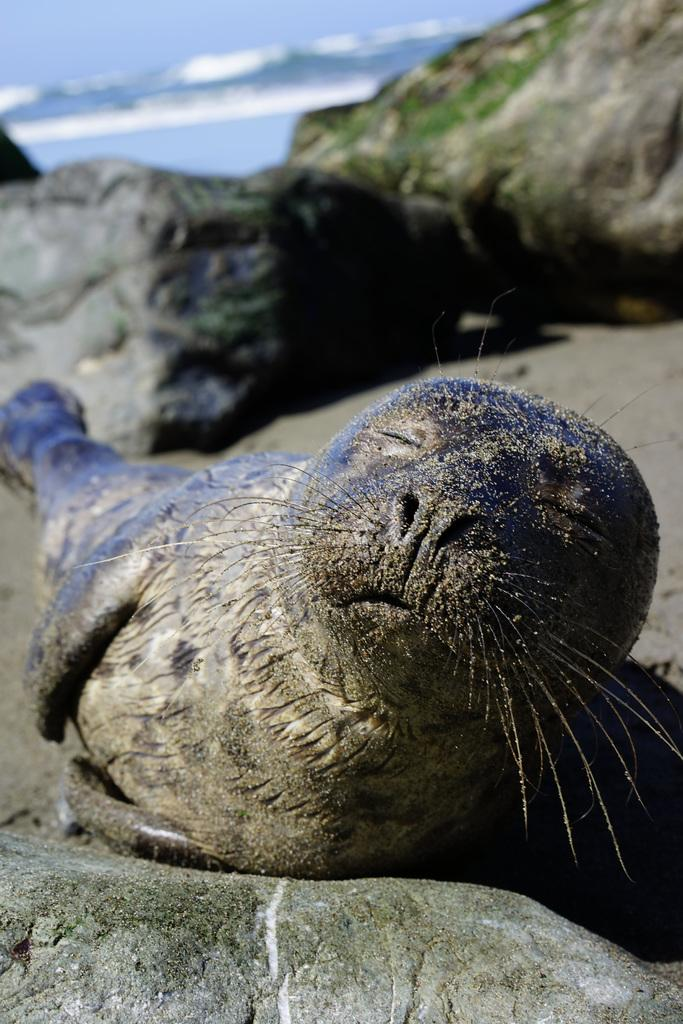What animal is on a stone in the image? There is a seal on a stone in the image. What can be seen in the background of the image? There are two stones near the sea shore in the background of the image. What is visible behind the stones in the background? There is water visible behind the stones in the background. What type of sidewalk can be seen near the seal in the image? There is no sidewalk present in the image; it features a seal on a stone near the sea shore. How many passengers are visible in the image? There are no passengers present in the image; it features a seal on a stone near the sea shore. 